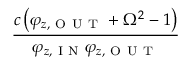Convert formula to latex. <formula><loc_0><loc_0><loc_500><loc_500>\frac { c \left ( \varphi _ { z , O U T } + \Omega ^ { 2 } - 1 \right ) } { \varphi _ { z , I N } \varphi _ { z , O U T } }</formula> 